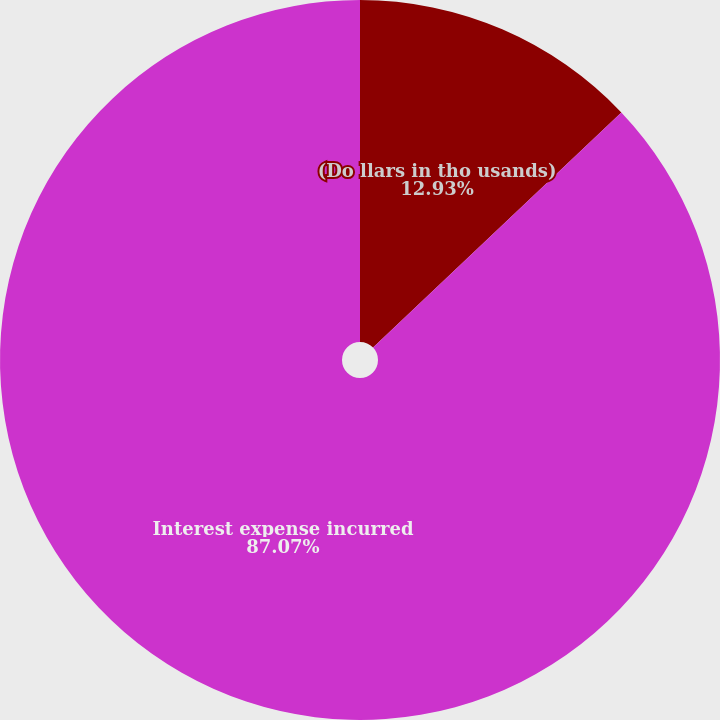Convert chart to OTSL. <chart><loc_0><loc_0><loc_500><loc_500><pie_chart><fcel>(Do llars in tho usands)<fcel>Interest expense incurred<nl><fcel>12.93%<fcel>87.07%<nl></chart> 